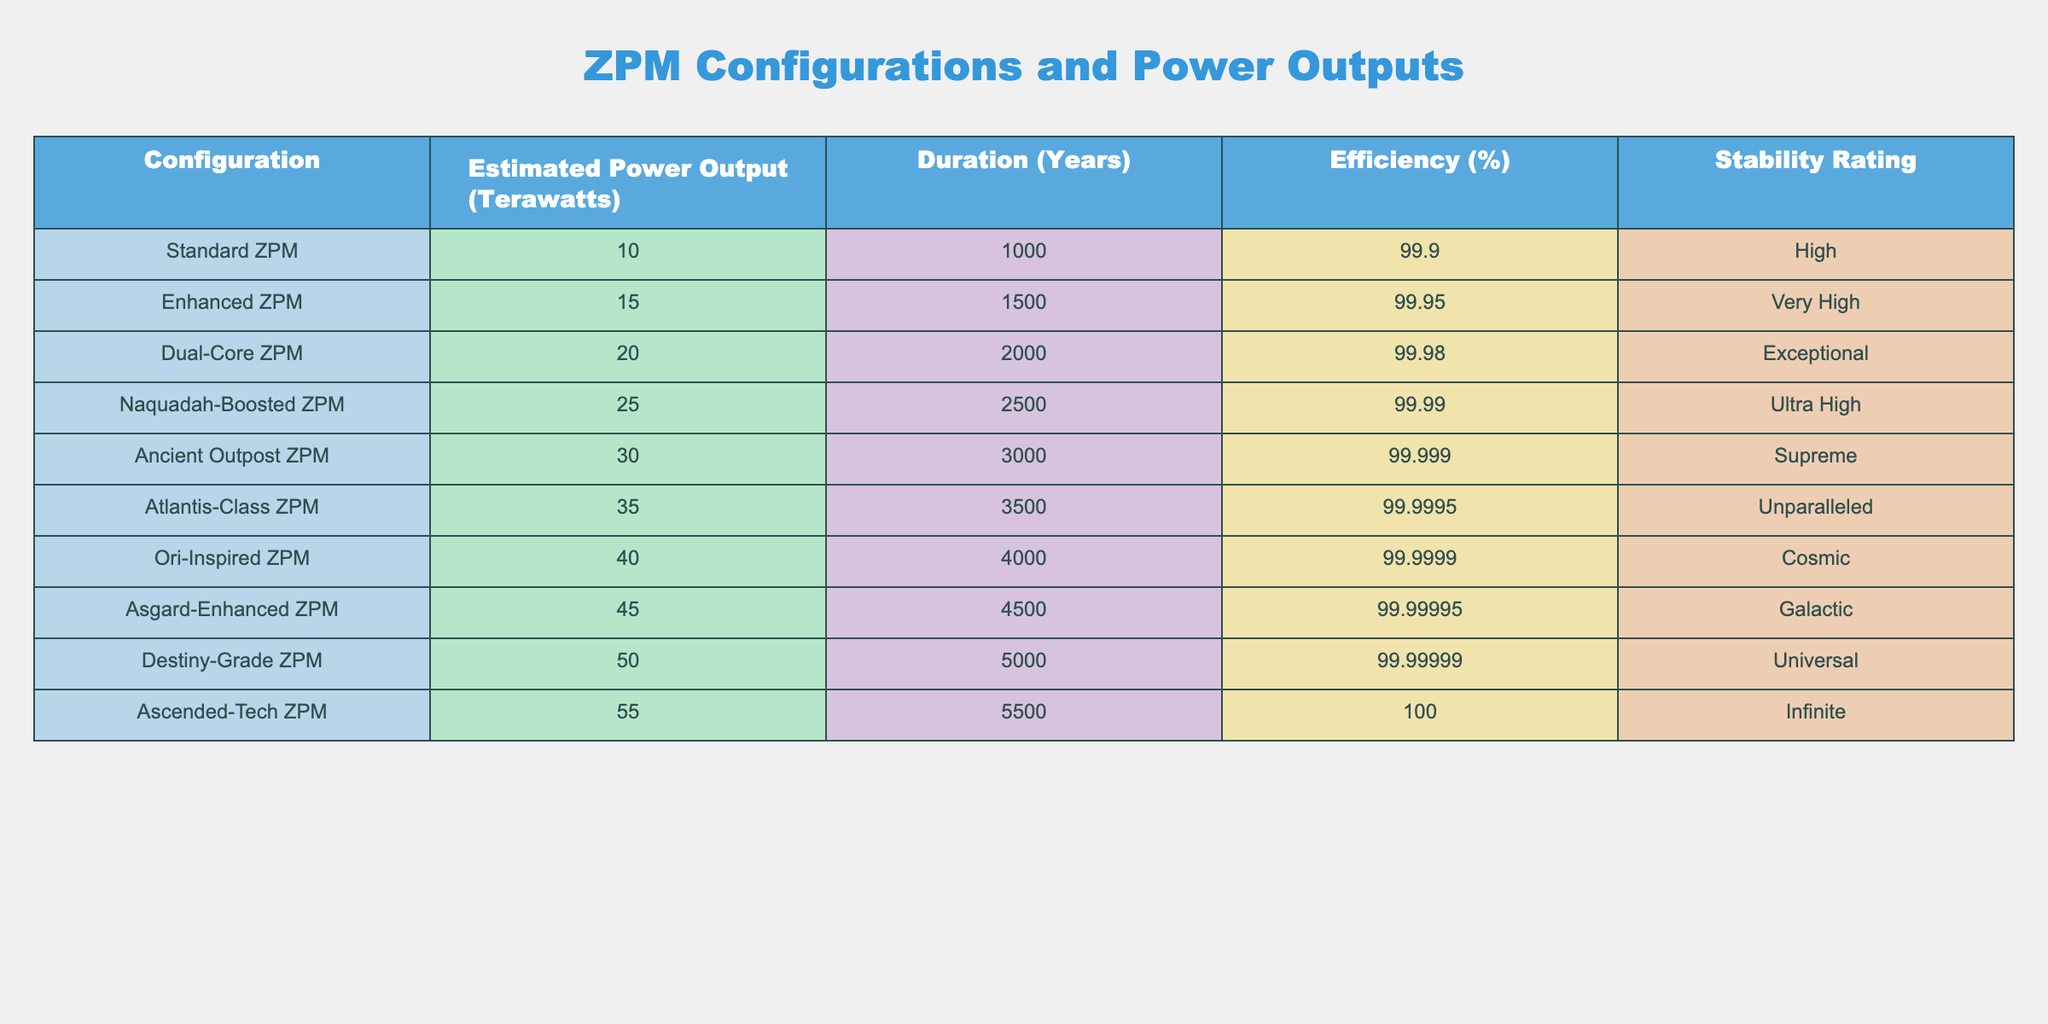What is the estimated power output of the Enhanced ZPM? The Enhanced ZPM configuration has a specific estimated power output mentioned in the table, which is listed clearly next to its name. Upon checking the corresponding value, it is found to be 15 terawatts.
Answer: 15 terawatts Which ZPM configuration has the highest stability rating? To determine which ZPM configuration has the highest stability rating, one can look at the stability rating column in the table. The highest stability rating listed is "Supreme" for the Ancient Outpost ZPM.
Answer: Ancient Outpost ZPM What is the average estimated power output of all ZPM configurations? The estimates for power outputs from the table are: 10, 15, 20, 25, 30, 35, 40, 45, 50, and 55 terawatts. Summing these values gives a total of 10 + 15 + 20 + 25 + 30 + 35 + 40 + 45 + 50 + 55 = 315 terawatts. There are 10 configurations, so the average is 315/10 = 31.5 terawatts.
Answer: 31.5 terawatts Is the efficiency of the Destiny-Grade ZPM greater than that of the Dual-Core ZPM? By examining the efficiency values in the table for both configurations, the Destiny-Grade ZPM has an efficiency of 99.99999%, while the Dual-Core ZPM has an efficiency of 99.98%. Since 99.99999% is greater than 99.98%, the statement is true.
Answer: Yes What is the difference in estimated power output between the Naquadah-Boosted ZPM and the Atlantis-Class ZPM? The estimated power output for the Naquadah-Boosted ZPM is 25 terawatts, and for the Atlantis-Class ZPM, it is 35 terawatts. The difference is calculated by subtracting the output of the Naquadah-Boosted ZPM from that of the Atlantis-Class ZPM: 35 - 25 = 10 terawatts.
Answer: 10 terawatts Which ZPM configuration has a power output closest to 50 terawatts? Observing the table, the configurations listed are: 10, 15, 20, 25, 30, 35, 40, 45, 50, and 55 terawatts. The closest value to 50 terawatts is 45 terawatts, which corresponds to the Asgard-Enhanced ZPM.
Answer: Asgard-Enhanced ZPM How many years can the Ascended-Tech ZPM last compared to the Standard ZPM? The duration of the Ascended-Tech ZPM is listed as 5500 years, whereas the Standard ZPM lasts 1000 years. To find the difference in duration: 5500 - 1000 = 4500 years. Thus, the Ascended-Tech ZPM lasts 4500 years longer than the Standard ZPM.
Answer: 4500 years Is it true that all ZPM configurations have an efficiency greater than 99%? Examining the efficiency values listed for each configuration, all efficiencies are above 99%, confirming the statement as true.
Answer: Yes Which ZPM configuration has the longest duration? The duration associated with each ZPM configuration can be found in the duration column. The longest duration listed is 5500 years for the Ascended-Tech ZPM.
Answer: Ascended-Tech ZPM What is the total estimated power output of all configurations that are rated "High" or better in stability? The configurations with a stability rating of "High" or better include: Standard ZPM (10), Enhanced ZPM (15), Dual-Core ZPM (20), Naquadah-Boosted ZPM (25), Ancient Outpost ZPM (30), Atlantis-Class ZPM (35), Ori-Inspired ZPM (40), Asgard-Enhanced ZPM (45), Destiny-Grade ZPM (50), and Ascended-Tech ZPM (55). Summing these values gives 10 + 15 + 20 + 25 + 30 + 35 + 40 + 45 + 50 + 55 = 315 terawatts.
Answer: 315 terawatts 